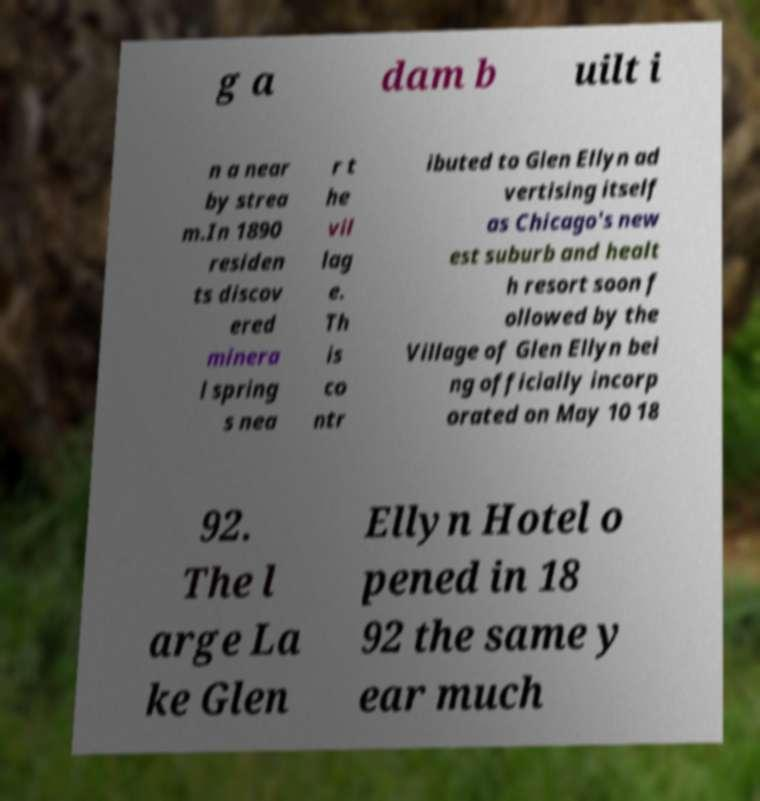Can you accurately transcribe the text from the provided image for me? g a dam b uilt i n a near by strea m.In 1890 residen ts discov ered minera l spring s nea r t he vil lag e. Th is co ntr ibuted to Glen Ellyn ad vertising itself as Chicago's new est suburb and healt h resort soon f ollowed by the Village of Glen Ellyn bei ng officially incorp orated on May 10 18 92. The l arge La ke Glen Ellyn Hotel o pened in 18 92 the same y ear much 